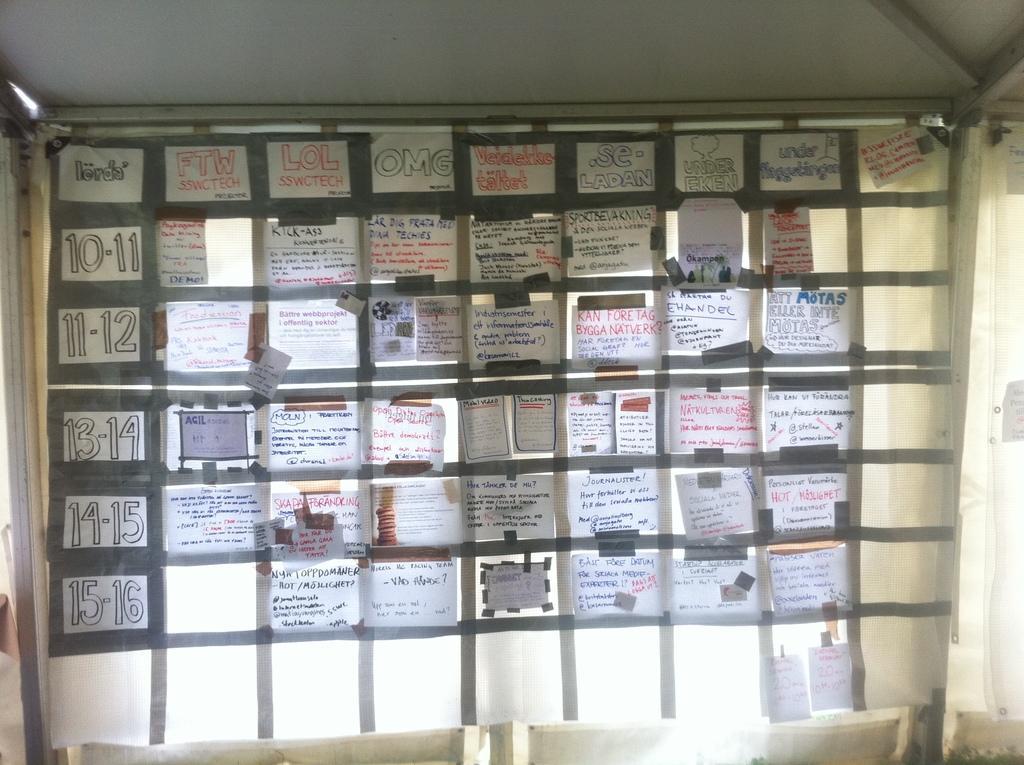In one or two sentences, can you explain what this image depicts? In this image there are papers pasted with the tapes on the white color cloth, which is tied to the iron poles. 